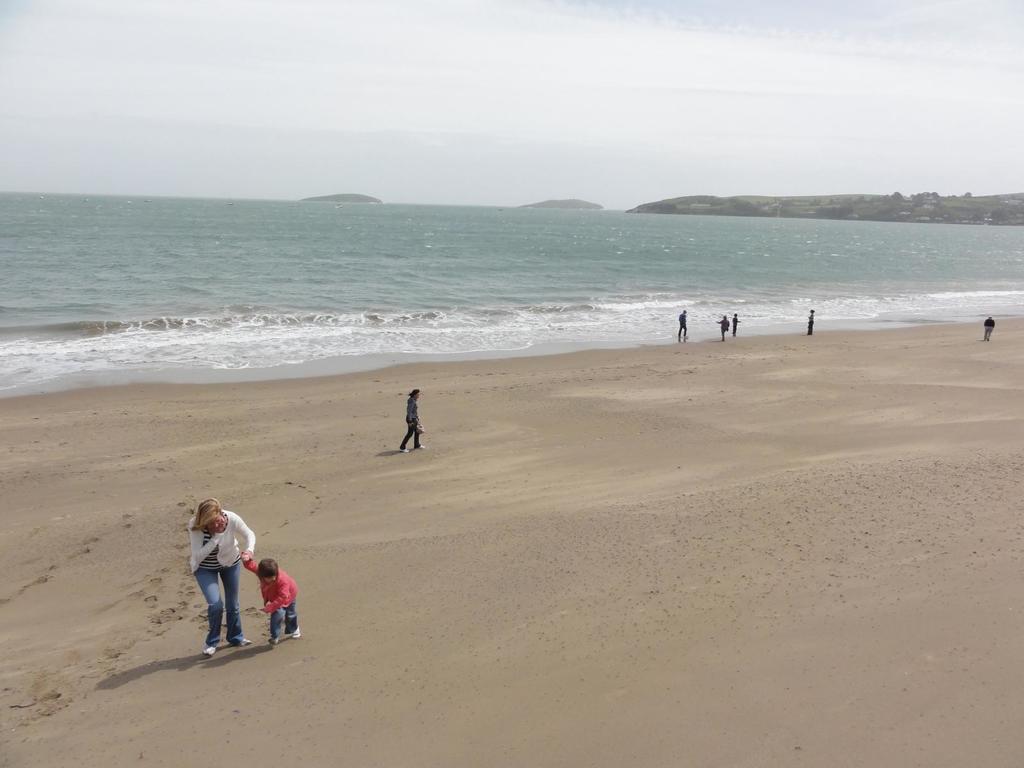Can you describe this image briefly? In the picture we can see a beach with sand and some people are walking and standing on it near the water and in the background we can see hills and a sky. 